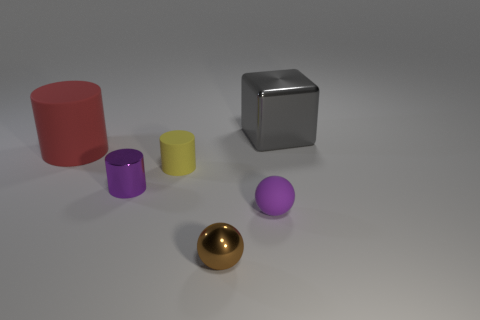Add 3 metallic cylinders. How many objects exist? 9 Subtract all blocks. How many objects are left? 5 Add 1 large green objects. How many large green objects exist? 1 Subtract 0 blue cylinders. How many objects are left? 6 Subtract all green rubber cylinders. Subtract all big shiny objects. How many objects are left? 5 Add 4 large gray cubes. How many large gray cubes are left? 5 